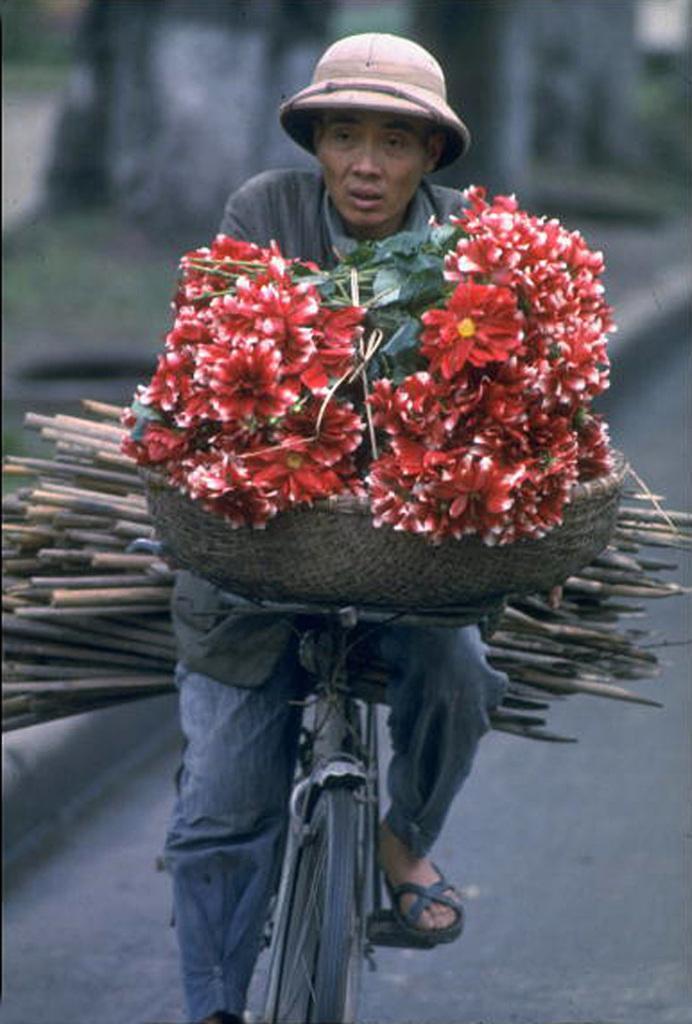Please provide a concise description of this image. He is riding a bicycle. Flowers in the basket in front of the bicycle. He is wearing a cap. 